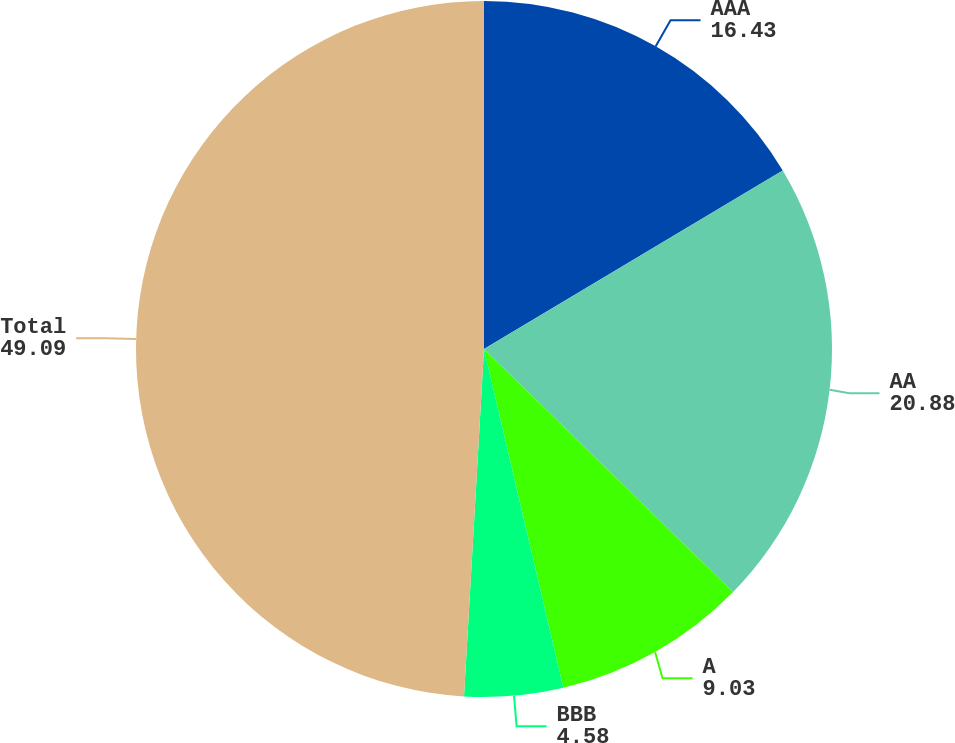Convert chart. <chart><loc_0><loc_0><loc_500><loc_500><pie_chart><fcel>AAA<fcel>AA<fcel>A<fcel>BBB<fcel>Total<nl><fcel>16.43%<fcel>20.88%<fcel>9.03%<fcel>4.58%<fcel>49.09%<nl></chart> 